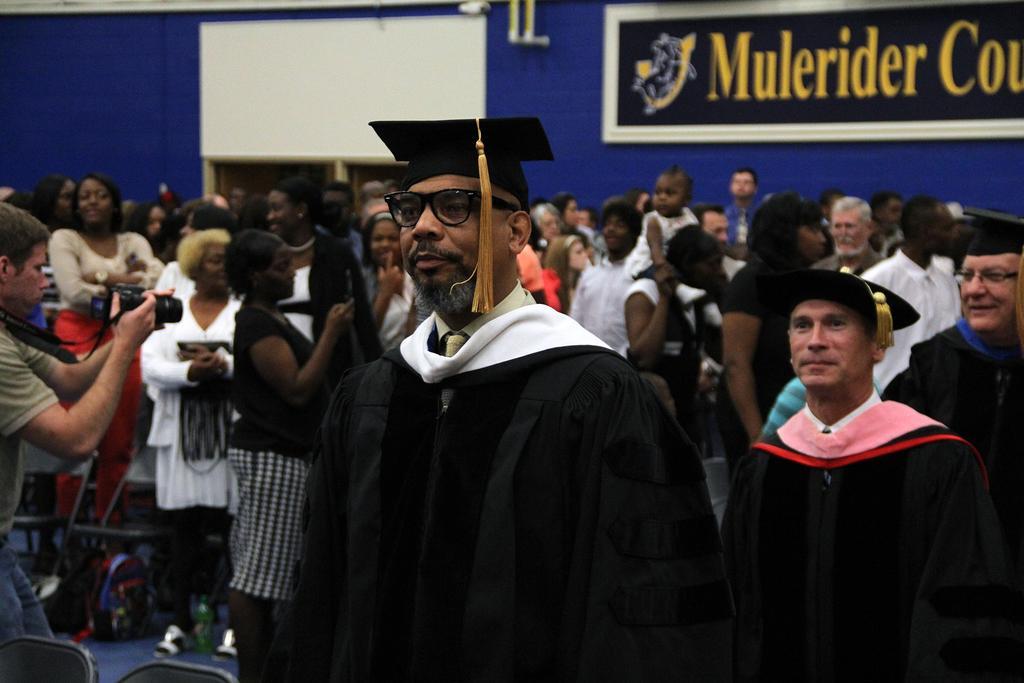How would you summarize this image in a sentence or two? In this image there are many people. There is a chair on the left bottom. There is a blue color wall. There is a board on the right top. There are cameras. 